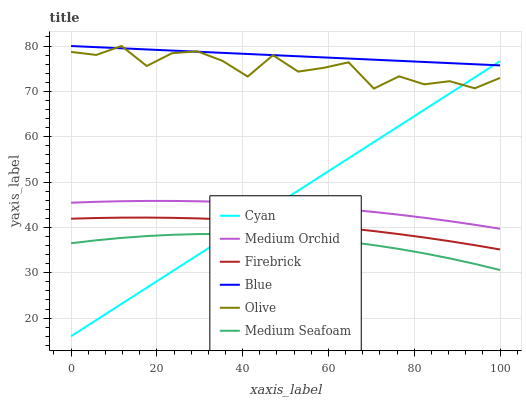Does Medium Seafoam have the minimum area under the curve?
Answer yes or no. Yes. Does Blue have the maximum area under the curve?
Answer yes or no. Yes. Does Firebrick have the minimum area under the curve?
Answer yes or no. No. Does Firebrick have the maximum area under the curve?
Answer yes or no. No. Is Cyan the smoothest?
Answer yes or no. Yes. Is Olive the roughest?
Answer yes or no. Yes. Is Firebrick the smoothest?
Answer yes or no. No. Is Firebrick the roughest?
Answer yes or no. No. Does Cyan have the lowest value?
Answer yes or no. Yes. Does Firebrick have the lowest value?
Answer yes or no. No. Does Olive have the highest value?
Answer yes or no. Yes. Does Firebrick have the highest value?
Answer yes or no. No. Is Firebrick less than Olive?
Answer yes or no. Yes. Is Medium Orchid greater than Medium Seafoam?
Answer yes or no. Yes. Does Cyan intersect Olive?
Answer yes or no. Yes. Is Cyan less than Olive?
Answer yes or no. No. Is Cyan greater than Olive?
Answer yes or no. No. Does Firebrick intersect Olive?
Answer yes or no. No. 